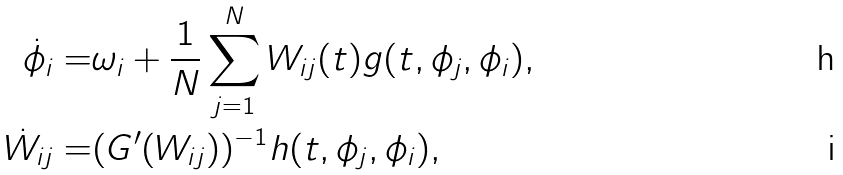<formula> <loc_0><loc_0><loc_500><loc_500>\dot { \phi } _ { i } = & \omega _ { i } + \frac { 1 } { N } \sum _ { j = 1 } ^ { N } W _ { i j } ( t ) g ( t , \phi _ { j } , \phi _ { i } ) , \\ \dot { W } _ { i j } = & ( G ^ { \prime } ( W _ { i j } ) ) ^ { - 1 } h ( t , \phi _ { j } , \phi _ { i } ) ,</formula> 